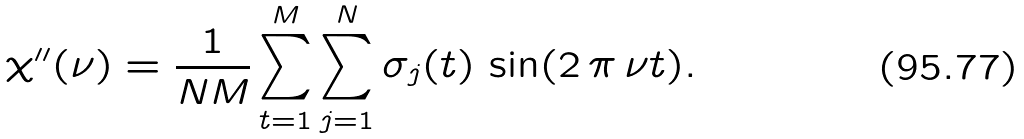<formula> <loc_0><loc_0><loc_500><loc_500>\chi ^ { \prime \prime } ( \nu ) = \frac { 1 } { N M } \sum _ { t = 1 } ^ { M } \sum _ { j = 1 } ^ { N } \sigma _ { j } ( t ) \, \sin ( 2 \, \pi \, \nu t ) .</formula> 